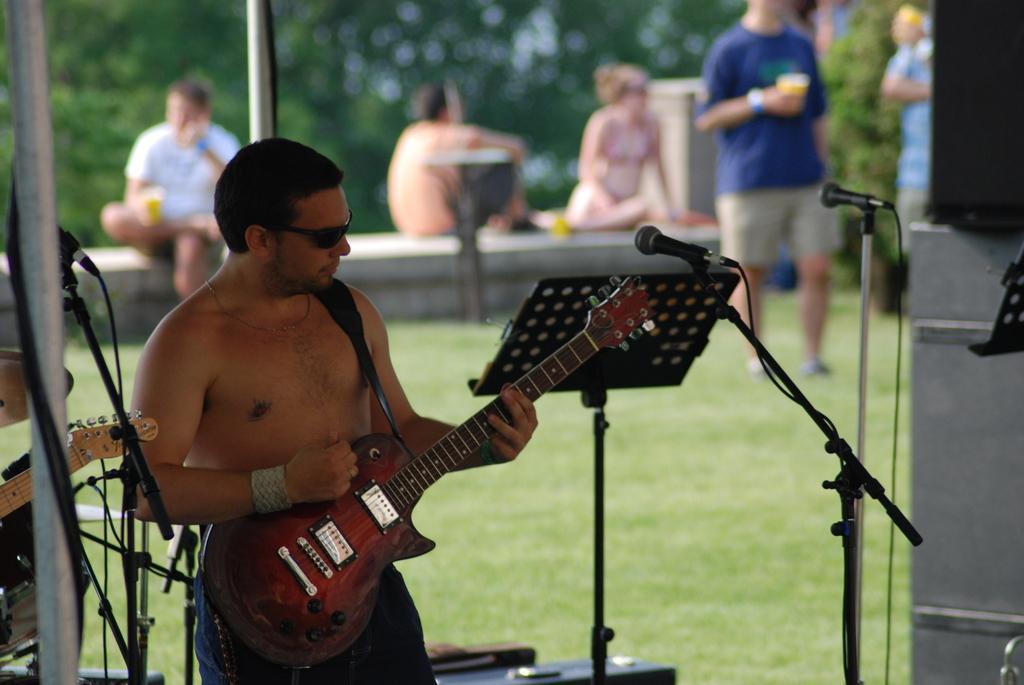In one or two sentences, can you explain what this image depicts? In this picture we can see a man who is playing a guitar. He has goggles and this is mike. On the background we can see some persons who are sitting. This is grass and these are the mikes. Here we can see some trees. 